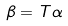<formula> <loc_0><loc_0><loc_500><loc_500>\beta = T \alpha</formula> 